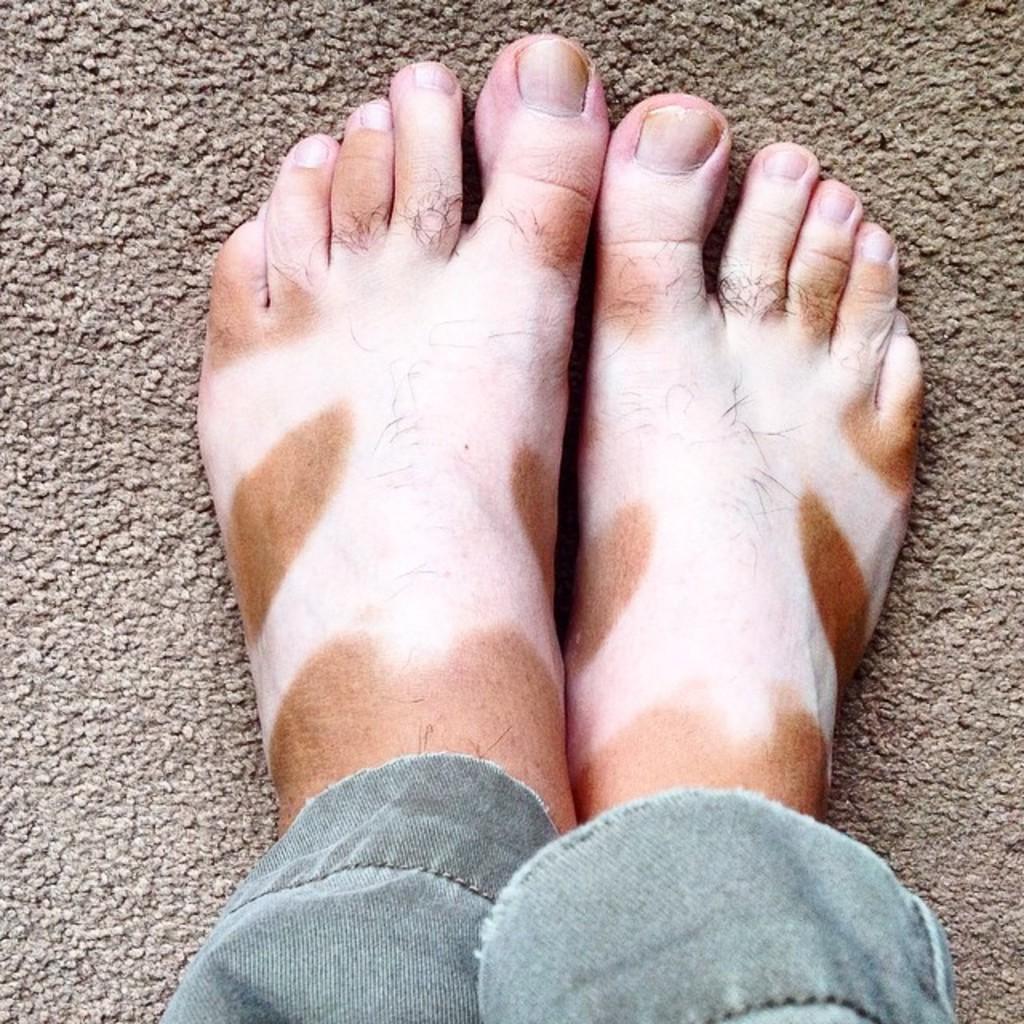Can you describe this image briefly? In this picture there is a person and the legs of the person are in two different colors. At the bottom there is a light brown mat. 